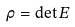Convert formula to latex. <formula><loc_0><loc_0><loc_500><loc_500>\rho = \det E</formula> 